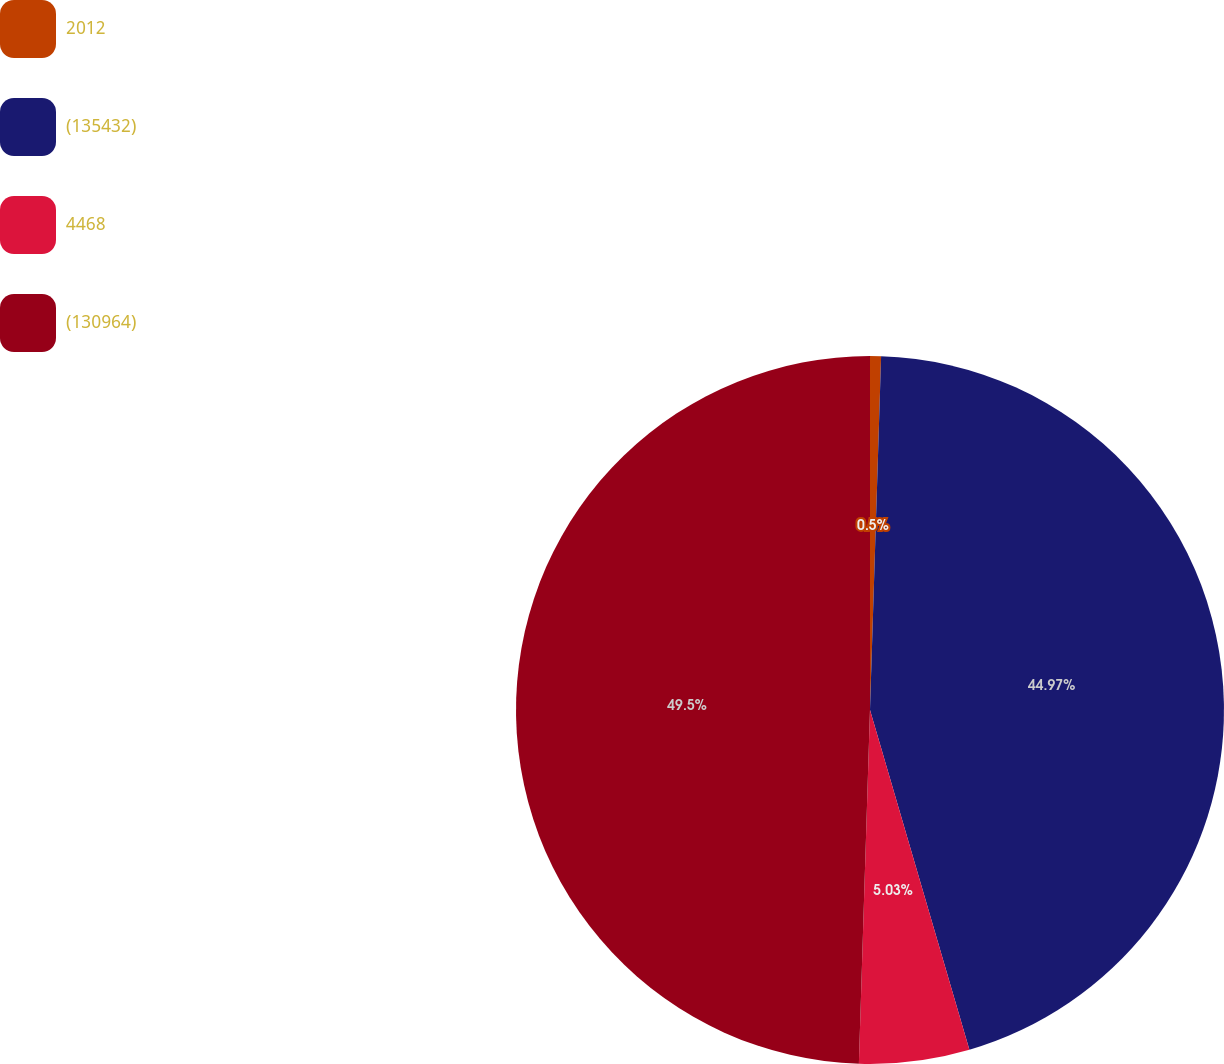Convert chart to OTSL. <chart><loc_0><loc_0><loc_500><loc_500><pie_chart><fcel>2012<fcel>(135432)<fcel>4468<fcel>(130964)<nl><fcel>0.5%<fcel>44.97%<fcel>5.03%<fcel>49.5%<nl></chart> 